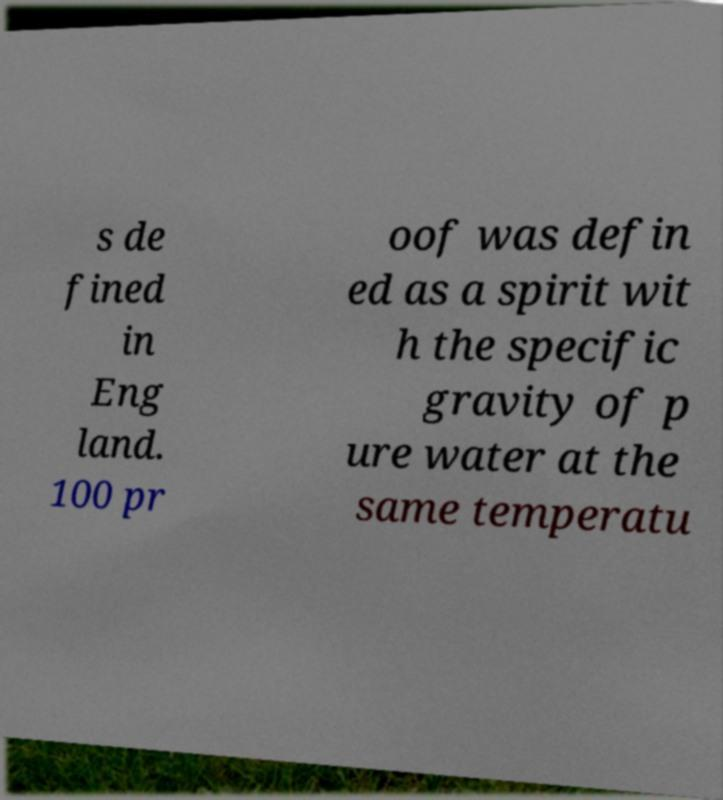There's text embedded in this image that I need extracted. Can you transcribe it verbatim? s de fined in Eng land. 100 pr oof was defin ed as a spirit wit h the specific gravity of p ure water at the same temperatu 